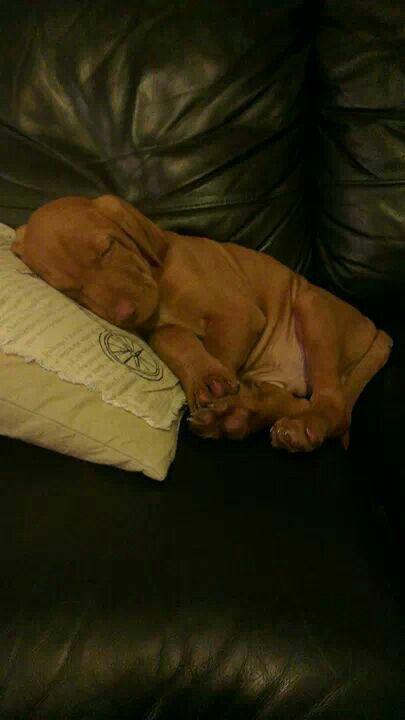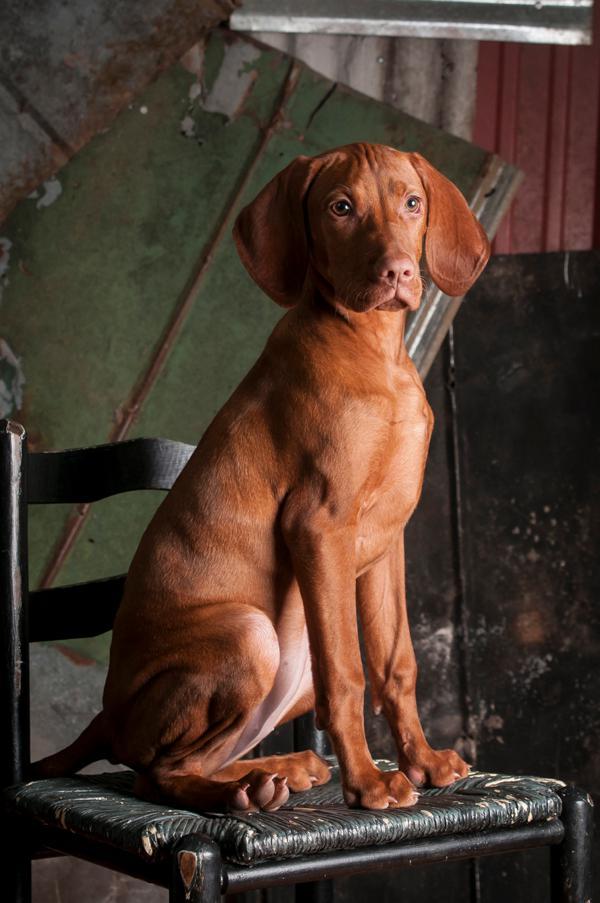The first image is the image on the left, the second image is the image on the right. For the images displayed, is the sentence "At least one dog is laying on a pillow." factually correct? Answer yes or no. Yes. The first image is the image on the left, the second image is the image on the right. Given the left and right images, does the statement "The left image shows a fog in a reclining pose, and the dark toes on the underside of a dog's front paw are visible in the image on the right." hold true? Answer yes or no. No. 